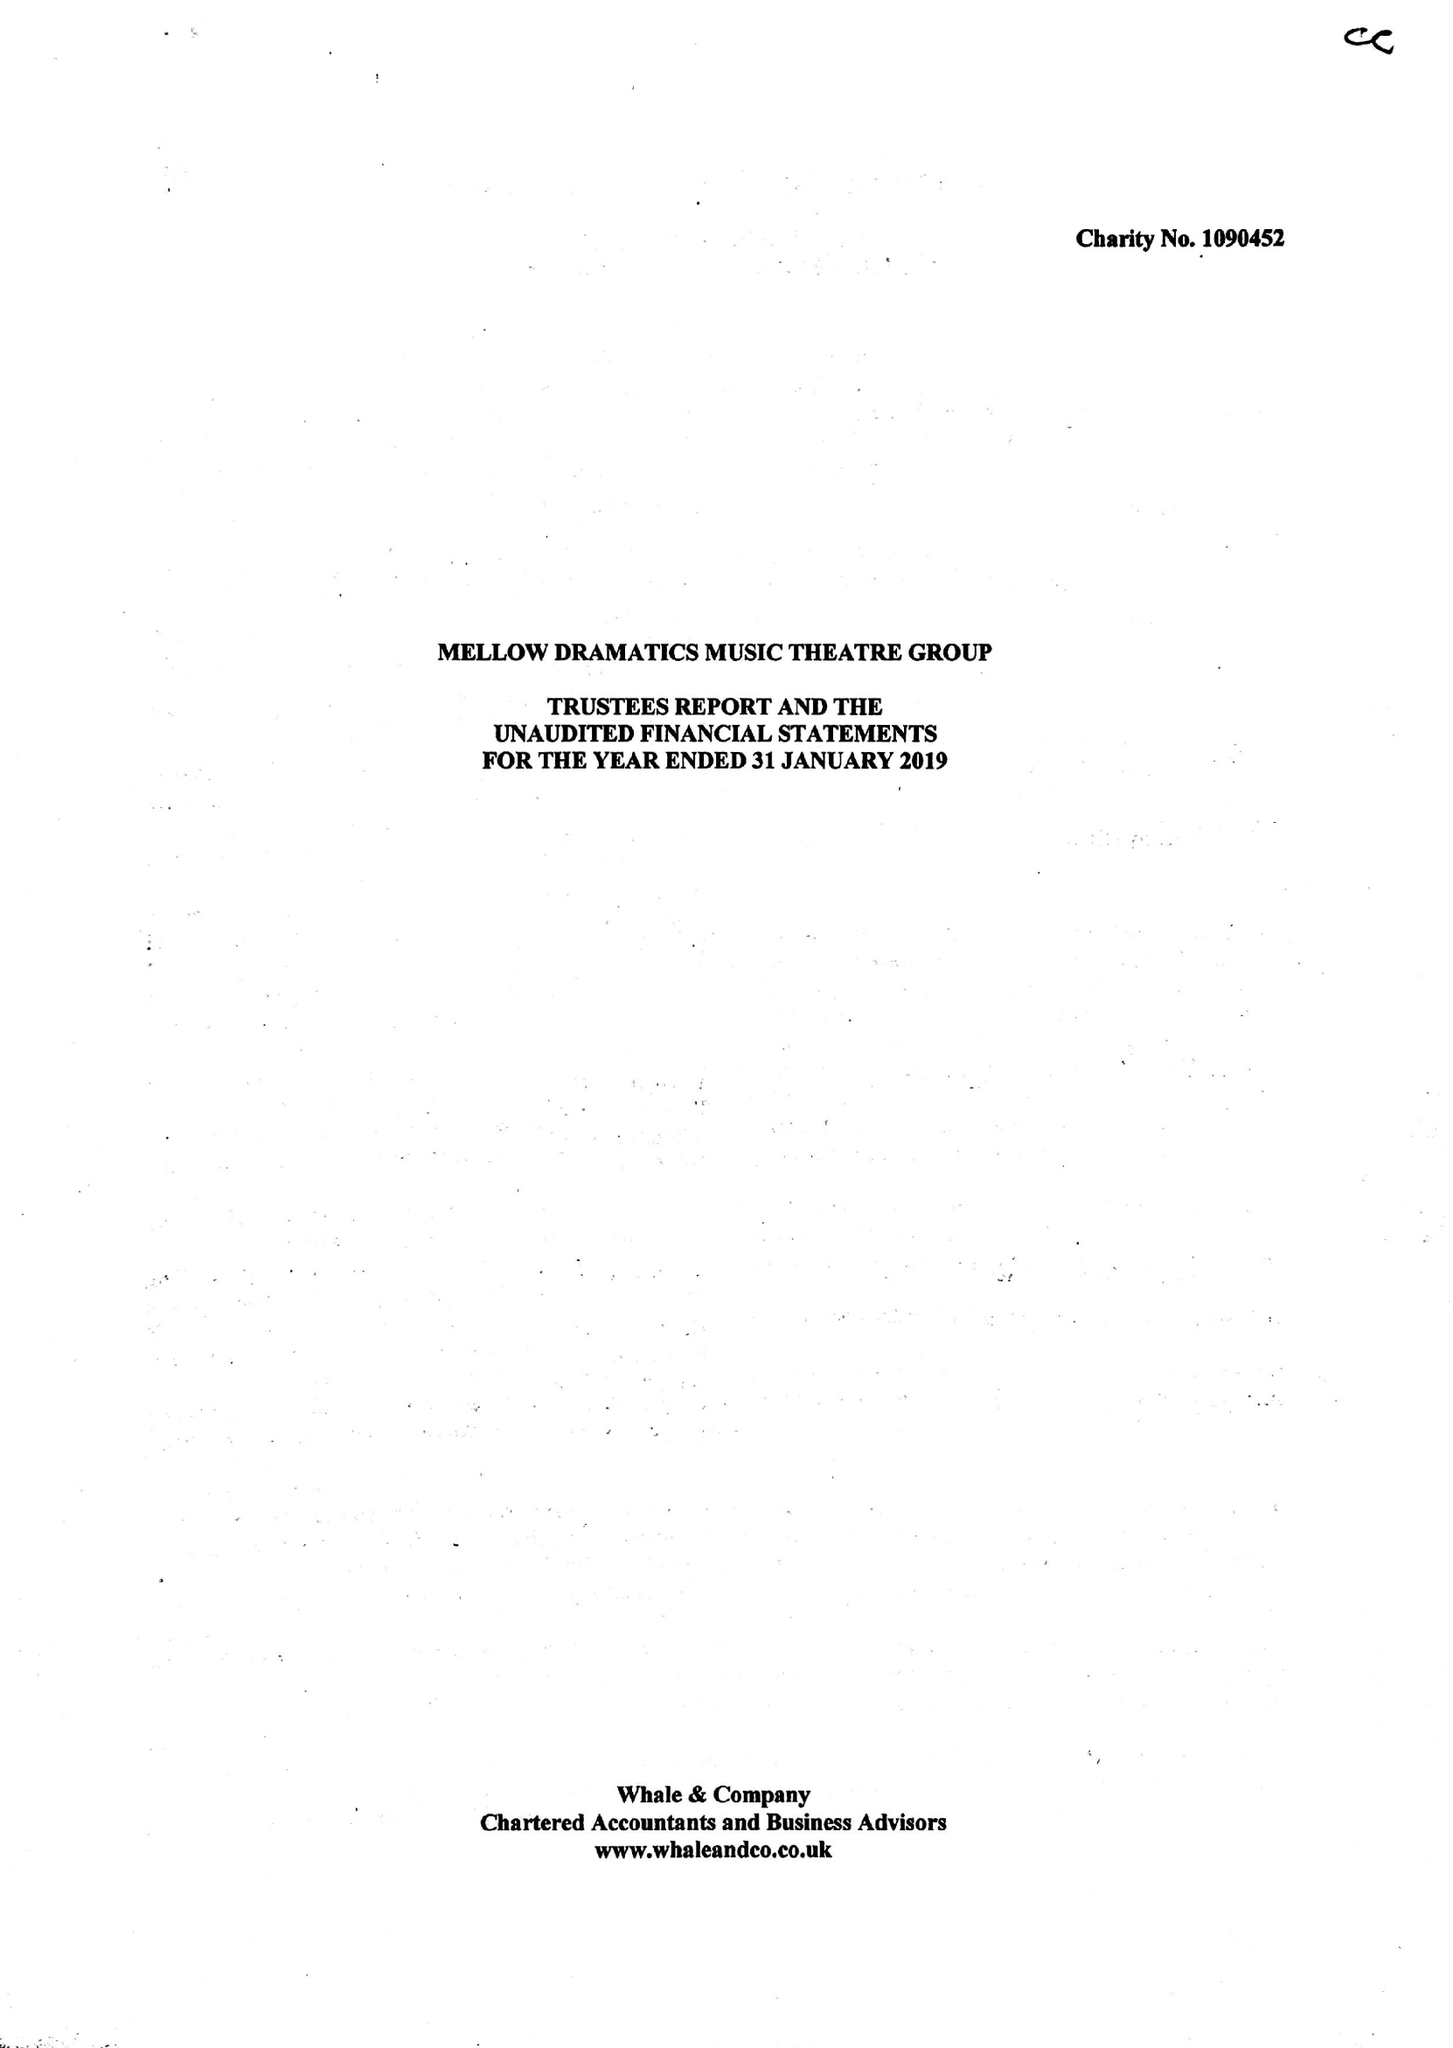What is the value for the charity_name?
Answer the question using a single word or phrase. Mellow Dramatics Music Theatre Group 